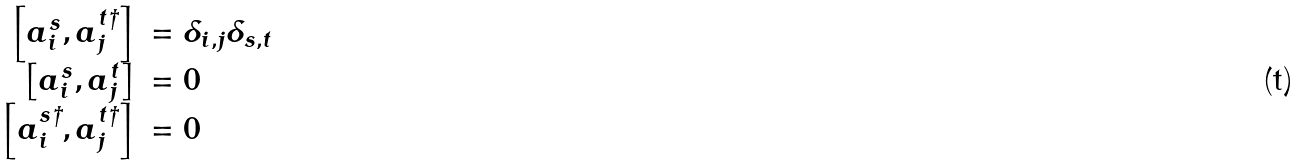Convert formula to latex. <formula><loc_0><loc_0><loc_500><loc_500>\begin{array} { r l } \left [ a _ { i } ^ { s } , a _ { j } ^ { t \dagger } \right ] & = \delta _ { i , j } \delta _ { s , t } \\ \left [ a _ { i } ^ { s } , a _ { j } ^ { t } \right ] & = 0 \\ \left [ a _ { i } ^ { s \dagger } , a _ { j } ^ { t \dagger } \right ] & = 0 \end{array}</formula> 